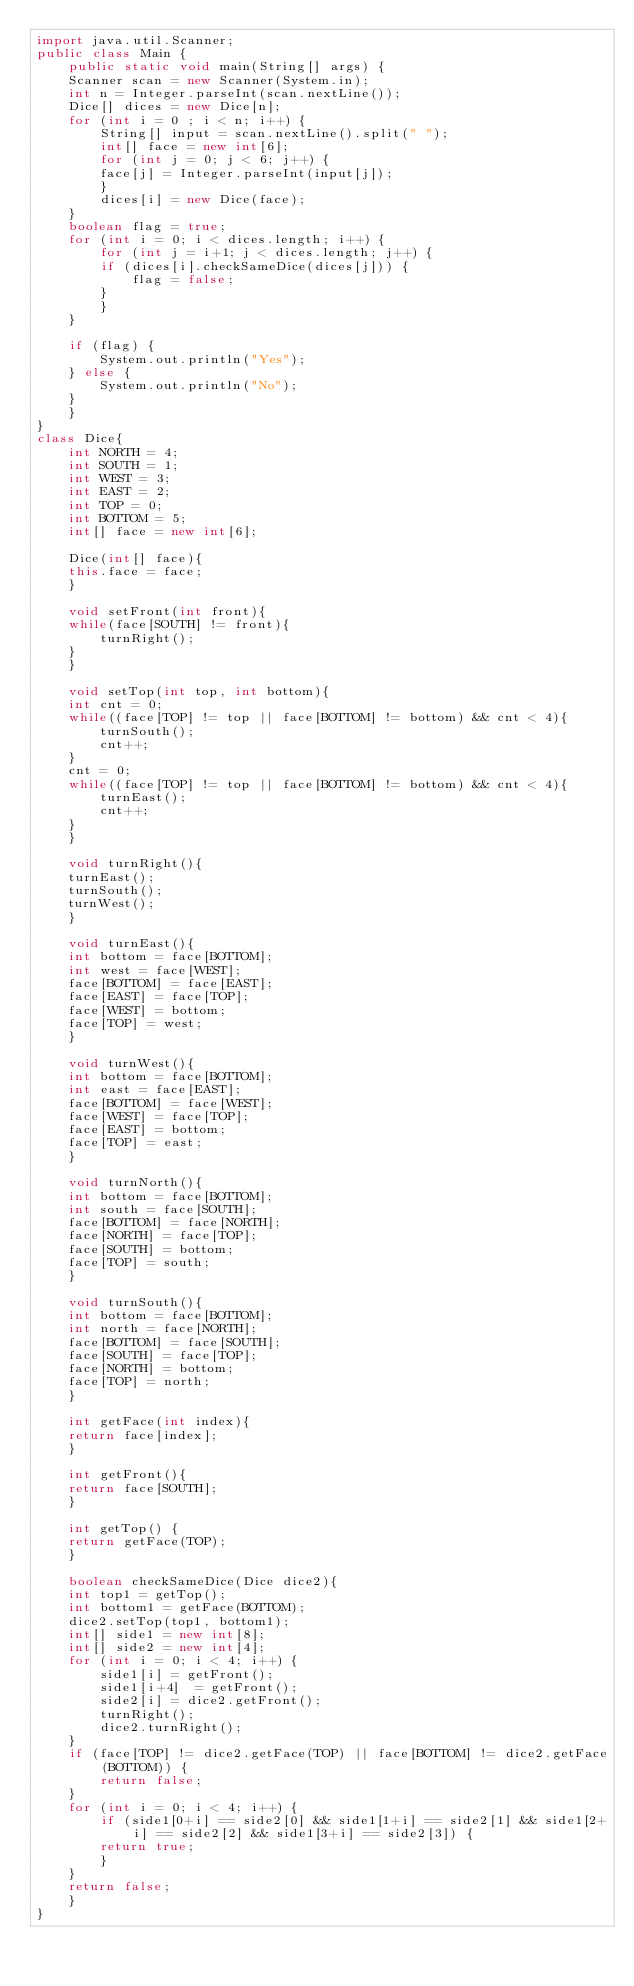<code> <loc_0><loc_0><loc_500><loc_500><_Java_>import java.util.Scanner;
public class Main {
    public static void main(String[] args) {
	Scanner scan = new Scanner(System.in);
	int n = Integer.parseInt(scan.nextLine());
	Dice[] dices = new Dice[n];
	for (int i = 0 ; i < n; i++) {
	    String[] input = scan.nextLine().split(" ");
	    int[] face = new int[6];
	    for (int j = 0; j < 6; j++) {
		face[j] = Integer.parseInt(input[j]);
	    }
	    dices[i] = new Dice(face);
	}
	boolean flag = true;
	for (int i = 0; i < dices.length; i++) {
	    for (int j = i+1; j < dices.length; j++) {
		if (dices[i].checkSameDice(dices[j])) {
		    flag = false; 
		}
	    }
	}

	if (flag) {
	    System.out.println("Yes");
	} else {
	    System.out.println("No");
	}
    }
}
class Dice{
    int NORTH = 4;
    int SOUTH = 1;
    int WEST = 3;
    int EAST = 2;
    int TOP = 0;
    int BOTTOM = 5;
    int[] face = new int[6];
	
    Dice(int[] face){
	this.face = face;
    }

    void setFront(int front){
	while(face[SOUTH] != front){
	    turnRight();
	}
    }
    
    void setTop(int top, int bottom){
	int cnt = 0;
	while((face[TOP] != top || face[BOTTOM] != bottom) && cnt < 4){
	    turnSouth();
	    cnt++;
	}
	cnt = 0;
	while((face[TOP] != top || face[BOTTOM] != bottom) && cnt < 4){
	    turnEast();
	    cnt++;
	}
    }

    void turnRight(){
	turnEast();
	turnSouth();
	turnWest();
    }

    void turnEast(){
	int bottom = face[BOTTOM];
	int west = face[WEST];
	face[BOTTOM] = face[EAST];
	face[EAST] = face[TOP];
	face[WEST] = bottom;
	face[TOP] = west;
    }

    void turnWest(){
	int bottom = face[BOTTOM];
	int east = face[EAST];
	face[BOTTOM] = face[WEST];
	face[WEST] = face[TOP];
	face[EAST] = bottom;
	face[TOP] = east;
    }
	
    void turnNorth(){
	int bottom = face[BOTTOM];
	int south = face[SOUTH];
	face[BOTTOM] = face[NORTH];
	face[NORTH] = face[TOP];
	face[SOUTH] = bottom;
	face[TOP] = south;
    }

    void turnSouth(){
	int bottom = face[BOTTOM];
	int north = face[NORTH];
	face[BOTTOM] = face[SOUTH];
	face[SOUTH] = face[TOP];
	face[NORTH] = bottom;
	face[TOP] = north;
    }
    
    int getFace(int index){
	return face[index];
    }

    int getFront(){
	return face[SOUTH];
    }
    
    int getTop() {
	return getFace(TOP);
    }

    boolean checkSameDice(Dice dice2){
	int top1 = getTop();
	int bottom1 = getFace(BOTTOM);
	dice2.setTop(top1, bottom1);
	int[] side1 = new int[8];
	int[] side2 = new int[4];
	for (int i = 0; i < 4; i++) {
	    side1[i] = getFront();
	    side1[i+4]  = getFront();
	    side2[i] = dice2.getFront();
	    turnRight();
	    dice2.turnRight();
	}
	if (face[TOP] != dice2.getFace(TOP) || face[BOTTOM] != dice2.getFace(BOTTOM)) {
	    return false;
	}
	for (int i = 0; i < 4; i++) {
	    if (side1[0+i] == side2[0] && side1[1+i] == side2[1] && side1[2+i] == side2[2] && side1[3+i] == side2[3]) {
		return true;
	    }
	}
	return false;
    }
}
    </code> 